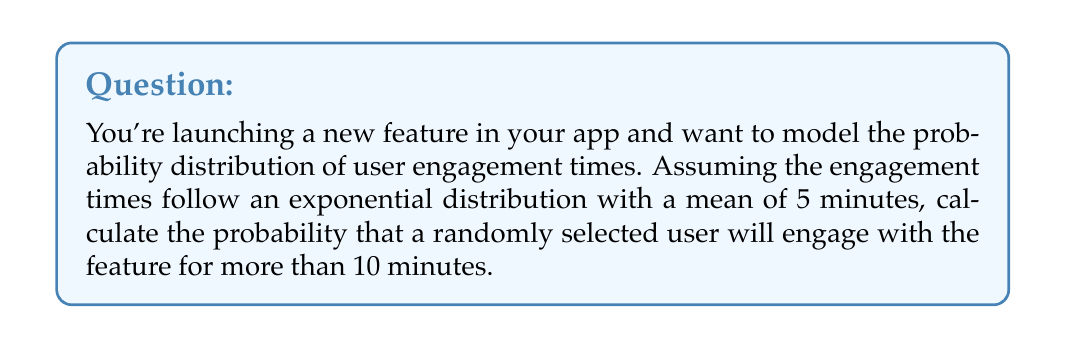Give your solution to this math problem. To solve this problem, we'll use the properties of the exponential distribution:

1. The probability density function (PDF) of an exponential distribution is given by:
   $$f(x) = \lambda e^{-\lambda x}$$
   where $\lambda$ is the rate parameter.

2. The mean of an exponential distribution is $\frac{1}{\lambda}$. Given that the mean engagement time is 5 minutes, we can calculate $\lambda$:
   $$\frac{1}{\lambda} = 5$$
   $$\lambda = \frac{1}{5} = 0.2$$

3. We want to find the probability of engaging for more than 10 minutes, which is the complement of engaging for 10 minutes or less. In mathematical terms:
   $$P(X > 10) = 1 - P(X \leq 10)$$

4. For an exponential distribution, the cumulative distribution function (CDF) is:
   $$F(x) = 1 - e^{-\lambda x}$$

5. Therefore, the probability of engaging for more than 10 minutes is:
   $$P(X > 10) = 1 - (1 - e^{-\lambda \cdot 10})$$
   $$P(X > 10) = e^{-\lambda \cdot 10}$$

6. Substituting the value of $\lambda$:
   $$P(X > 10) = e^{-0.2 \cdot 10}$$
   $$P(X > 10) = e^{-2}$$

7. Calculate the final result:
   $$P(X > 10) \approx 0.1353$$

Thus, the probability that a randomly selected user will engage with the feature for more than 10 minutes is approximately 0.1353 or 13.53%.
Answer: $e^{-2} \approx 0.1353$ or 13.53% 